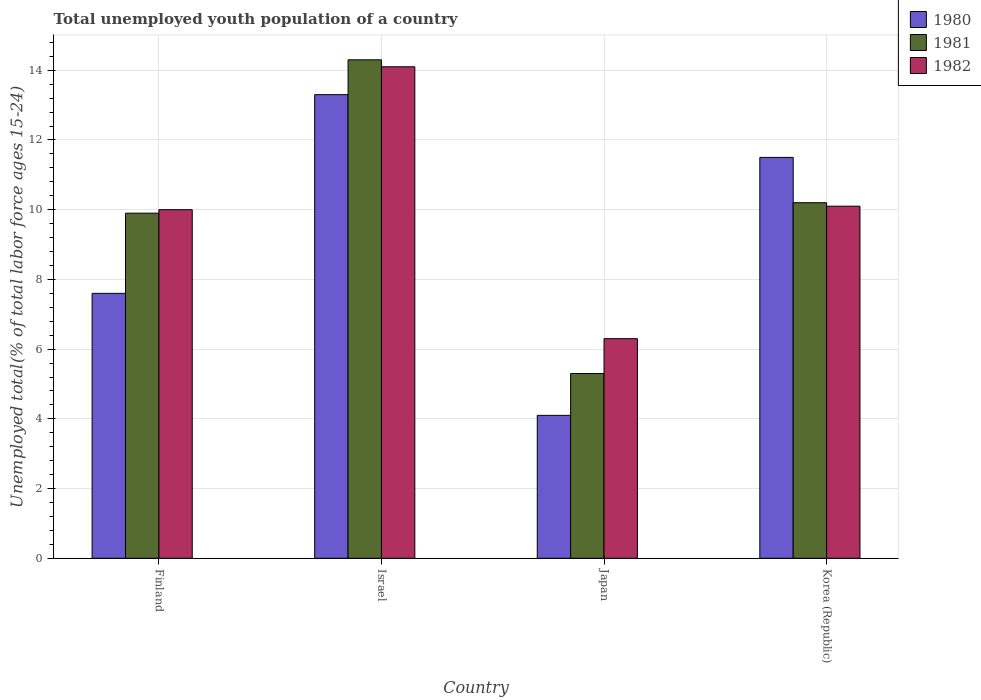How many bars are there on the 4th tick from the right?
Your response must be concise. 3. In how many cases, is the number of bars for a given country not equal to the number of legend labels?
Provide a succinct answer. 0. What is the percentage of total unemployed youth population of a country in 1982 in Korea (Republic)?
Your answer should be compact. 10.1. Across all countries, what is the maximum percentage of total unemployed youth population of a country in 1982?
Give a very brief answer. 14.1. Across all countries, what is the minimum percentage of total unemployed youth population of a country in 1980?
Provide a succinct answer. 4.1. In which country was the percentage of total unemployed youth population of a country in 1982 minimum?
Provide a succinct answer. Japan. What is the total percentage of total unemployed youth population of a country in 1981 in the graph?
Your answer should be very brief. 39.7. What is the difference between the percentage of total unemployed youth population of a country in 1981 in Japan and that in Korea (Republic)?
Provide a succinct answer. -4.9. What is the difference between the percentage of total unemployed youth population of a country in 1981 in Israel and the percentage of total unemployed youth population of a country in 1982 in Finland?
Keep it short and to the point. 4.3. What is the average percentage of total unemployed youth population of a country in 1981 per country?
Your answer should be very brief. 9.92. What is the difference between the percentage of total unemployed youth population of a country of/in 1982 and percentage of total unemployed youth population of a country of/in 1980 in Korea (Republic)?
Give a very brief answer. -1.4. In how many countries, is the percentage of total unemployed youth population of a country in 1982 greater than 8.4 %?
Give a very brief answer. 3. What is the ratio of the percentage of total unemployed youth population of a country in 1980 in Finland to that in Korea (Republic)?
Ensure brevity in your answer.  0.66. Is the percentage of total unemployed youth population of a country in 1980 in Israel less than that in Korea (Republic)?
Provide a succinct answer. No. What is the difference between the highest and the second highest percentage of total unemployed youth population of a country in 1981?
Keep it short and to the point. -0.3. What is the difference between the highest and the lowest percentage of total unemployed youth population of a country in 1980?
Ensure brevity in your answer.  9.2. In how many countries, is the percentage of total unemployed youth population of a country in 1980 greater than the average percentage of total unemployed youth population of a country in 1980 taken over all countries?
Give a very brief answer. 2. Is the sum of the percentage of total unemployed youth population of a country in 1980 in Finland and Japan greater than the maximum percentage of total unemployed youth population of a country in 1981 across all countries?
Your answer should be very brief. No. What does the 1st bar from the left in Korea (Republic) represents?
Keep it short and to the point. 1980. What does the 3rd bar from the right in Israel represents?
Your response must be concise. 1980. How many bars are there?
Make the answer very short. 12. Are all the bars in the graph horizontal?
Your answer should be compact. No. How many countries are there in the graph?
Ensure brevity in your answer.  4. Are the values on the major ticks of Y-axis written in scientific E-notation?
Provide a succinct answer. No. Does the graph contain any zero values?
Give a very brief answer. No. How many legend labels are there?
Your answer should be very brief. 3. What is the title of the graph?
Offer a very short reply. Total unemployed youth population of a country. What is the label or title of the Y-axis?
Provide a succinct answer. Unemployed total(% of total labor force ages 15-24). What is the Unemployed total(% of total labor force ages 15-24) in 1980 in Finland?
Ensure brevity in your answer.  7.6. What is the Unemployed total(% of total labor force ages 15-24) of 1981 in Finland?
Provide a succinct answer. 9.9. What is the Unemployed total(% of total labor force ages 15-24) in 1982 in Finland?
Offer a terse response. 10. What is the Unemployed total(% of total labor force ages 15-24) of 1980 in Israel?
Your answer should be compact. 13.3. What is the Unemployed total(% of total labor force ages 15-24) of 1981 in Israel?
Your response must be concise. 14.3. What is the Unemployed total(% of total labor force ages 15-24) in 1982 in Israel?
Keep it short and to the point. 14.1. What is the Unemployed total(% of total labor force ages 15-24) of 1980 in Japan?
Your answer should be compact. 4.1. What is the Unemployed total(% of total labor force ages 15-24) of 1981 in Japan?
Offer a terse response. 5.3. What is the Unemployed total(% of total labor force ages 15-24) of 1982 in Japan?
Ensure brevity in your answer.  6.3. What is the Unemployed total(% of total labor force ages 15-24) in 1980 in Korea (Republic)?
Make the answer very short. 11.5. What is the Unemployed total(% of total labor force ages 15-24) in 1981 in Korea (Republic)?
Give a very brief answer. 10.2. What is the Unemployed total(% of total labor force ages 15-24) of 1982 in Korea (Republic)?
Your answer should be very brief. 10.1. Across all countries, what is the maximum Unemployed total(% of total labor force ages 15-24) of 1980?
Your answer should be very brief. 13.3. Across all countries, what is the maximum Unemployed total(% of total labor force ages 15-24) in 1981?
Your answer should be very brief. 14.3. Across all countries, what is the maximum Unemployed total(% of total labor force ages 15-24) of 1982?
Ensure brevity in your answer.  14.1. Across all countries, what is the minimum Unemployed total(% of total labor force ages 15-24) of 1980?
Your response must be concise. 4.1. Across all countries, what is the minimum Unemployed total(% of total labor force ages 15-24) in 1981?
Offer a very short reply. 5.3. Across all countries, what is the minimum Unemployed total(% of total labor force ages 15-24) of 1982?
Offer a very short reply. 6.3. What is the total Unemployed total(% of total labor force ages 15-24) of 1980 in the graph?
Your answer should be very brief. 36.5. What is the total Unemployed total(% of total labor force ages 15-24) in 1981 in the graph?
Keep it short and to the point. 39.7. What is the total Unemployed total(% of total labor force ages 15-24) of 1982 in the graph?
Keep it short and to the point. 40.5. What is the difference between the Unemployed total(% of total labor force ages 15-24) of 1980 in Finland and that in Israel?
Offer a terse response. -5.7. What is the difference between the Unemployed total(% of total labor force ages 15-24) of 1981 in Finland and that in Israel?
Your answer should be compact. -4.4. What is the difference between the Unemployed total(% of total labor force ages 15-24) in 1982 in Finland and that in Israel?
Your answer should be compact. -4.1. What is the difference between the Unemployed total(% of total labor force ages 15-24) in 1980 in Finland and that in Japan?
Your answer should be very brief. 3.5. What is the difference between the Unemployed total(% of total labor force ages 15-24) of 1980 in Finland and that in Korea (Republic)?
Make the answer very short. -3.9. What is the difference between the Unemployed total(% of total labor force ages 15-24) of 1981 in Finland and that in Korea (Republic)?
Ensure brevity in your answer.  -0.3. What is the difference between the Unemployed total(% of total labor force ages 15-24) in 1982 in Finland and that in Korea (Republic)?
Ensure brevity in your answer.  -0.1. What is the difference between the Unemployed total(% of total labor force ages 15-24) in 1980 in Israel and that in Japan?
Your response must be concise. 9.2. What is the difference between the Unemployed total(% of total labor force ages 15-24) of 1982 in Israel and that in Korea (Republic)?
Offer a terse response. 4. What is the difference between the Unemployed total(% of total labor force ages 15-24) in 1980 in Japan and that in Korea (Republic)?
Ensure brevity in your answer.  -7.4. What is the difference between the Unemployed total(% of total labor force ages 15-24) of 1981 in Finland and the Unemployed total(% of total labor force ages 15-24) of 1982 in Israel?
Offer a very short reply. -4.2. What is the difference between the Unemployed total(% of total labor force ages 15-24) of 1981 in Finland and the Unemployed total(% of total labor force ages 15-24) of 1982 in Korea (Republic)?
Keep it short and to the point. -0.2. What is the difference between the Unemployed total(% of total labor force ages 15-24) in 1980 in Israel and the Unemployed total(% of total labor force ages 15-24) in 1982 in Japan?
Offer a terse response. 7. What is the difference between the Unemployed total(% of total labor force ages 15-24) of 1980 in Israel and the Unemployed total(% of total labor force ages 15-24) of 1981 in Korea (Republic)?
Offer a very short reply. 3.1. What is the difference between the Unemployed total(% of total labor force ages 15-24) of 1981 in Israel and the Unemployed total(% of total labor force ages 15-24) of 1982 in Korea (Republic)?
Keep it short and to the point. 4.2. What is the difference between the Unemployed total(% of total labor force ages 15-24) in 1981 in Japan and the Unemployed total(% of total labor force ages 15-24) in 1982 in Korea (Republic)?
Make the answer very short. -4.8. What is the average Unemployed total(% of total labor force ages 15-24) of 1980 per country?
Provide a short and direct response. 9.12. What is the average Unemployed total(% of total labor force ages 15-24) of 1981 per country?
Keep it short and to the point. 9.93. What is the average Unemployed total(% of total labor force ages 15-24) of 1982 per country?
Make the answer very short. 10.12. What is the difference between the Unemployed total(% of total labor force ages 15-24) in 1980 and Unemployed total(% of total labor force ages 15-24) in 1981 in Israel?
Your response must be concise. -1. What is the difference between the Unemployed total(% of total labor force ages 15-24) of 1980 and Unemployed total(% of total labor force ages 15-24) of 1981 in Japan?
Your answer should be very brief. -1.2. What is the difference between the Unemployed total(% of total labor force ages 15-24) of 1980 and Unemployed total(% of total labor force ages 15-24) of 1981 in Korea (Republic)?
Make the answer very short. 1.3. What is the ratio of the Unemployed total(% of total labor force ages 15-24) of 1981 in Finland to that in Israel?
Offer a very short reply. 0.69. What is the ratio of the Unemployed total(% of total labor force ages 15-24) of 1982 in Finland to that in Israel?
Offer a very short reply. 0.71. What is the ratio of the Unemployed total(% of total labor force ages 15-24) in 1980 in Finland to that in Japan?
Provide a succinct answer. 1.85. What is the ratio of the Unemployed total(% of total labor force ages 15-24) of 1981 in Finland to that in Japan?
Offer a very short reply. 1.87. What is the ratio of the Unemployed total(% of total labor force ages 15-24) in 1982 in Finland to that in Japan?
Provide a succinct answer. 1.59. What is the ratio of the Unemployed total(% of total labor force ages 15-24) of 1980 in Finland to that in Korea (Republic)?
Offer a terse response. 0.66. What is the ratio of the Unemployed total(% of total labor force ages 15-24) of 1981 in Finland to that in Korea (Republic)?
Your answer should be very brief. 0.97. What is the ratio of the Unemployed total(% of total labor force ages 15-24) of 1982 in Finland to that in Korea (Republic)?
Ensure brevity in your answer.  0.99. What is the ratio of the Unemployed total(% of total labor force ages 15-24) in 1980 in Israel to that in Japan?
Offer a terse response. 3.24. What is the ratio of the Unemployed total(% of total labor force ages 15-24) of 1981 in Israel to that in Japan?
Your answer should be compact. 2.7. What is the ratio of the Unemployed total(% of total labor force ages 15-24) of 1982 in Israel to that in Japan?
Give a very brief answer. 2.24. What is the ratio of the Unemployed total(% of total labor force ages 15-24) in 1980 in Israel to that in Korea (Republic)?
Your response must be concise. 1.16. What is the ratio of the Unemployed total(% of total labor force ages 15-24) of 1981 in Israel to that in Korea (Republic)?
Provide a succinct answer. 1.4. What is the ratio of the Unemployed total(% of total labor force ages 15-24) in 1982 in Israel to that in Korea (Republic)?
Keep it short and to the point. 1.4. What is the ratio of the Unemployed total(% of total labor force ages 15-24) of 1980 in Japan to that in Korea (Republic)?
Give a very brief answer. 0.36. What is the ratio of the Unemployed total(% of total labor force ages 15-24) in 1981 in Japan to that in Korea (Republic)?
Your response must be concise. 0.52. What is the ratio of the Unemployed total(% of total labor force ages 15-24) in 1982 in Japan to that in Korea (Republic)?
Provide a succinct answer. 0.62. What is the difference between the highest and the second highest Unemployed total(% of total labor force ages 15-24) in 1980?
Give a very brief answer. 1.8. What is the difference between the highest and the lowest Unemployed total(% of total labor force ages 15-24) of 1982?
Give a very brief answer. 7.8. 